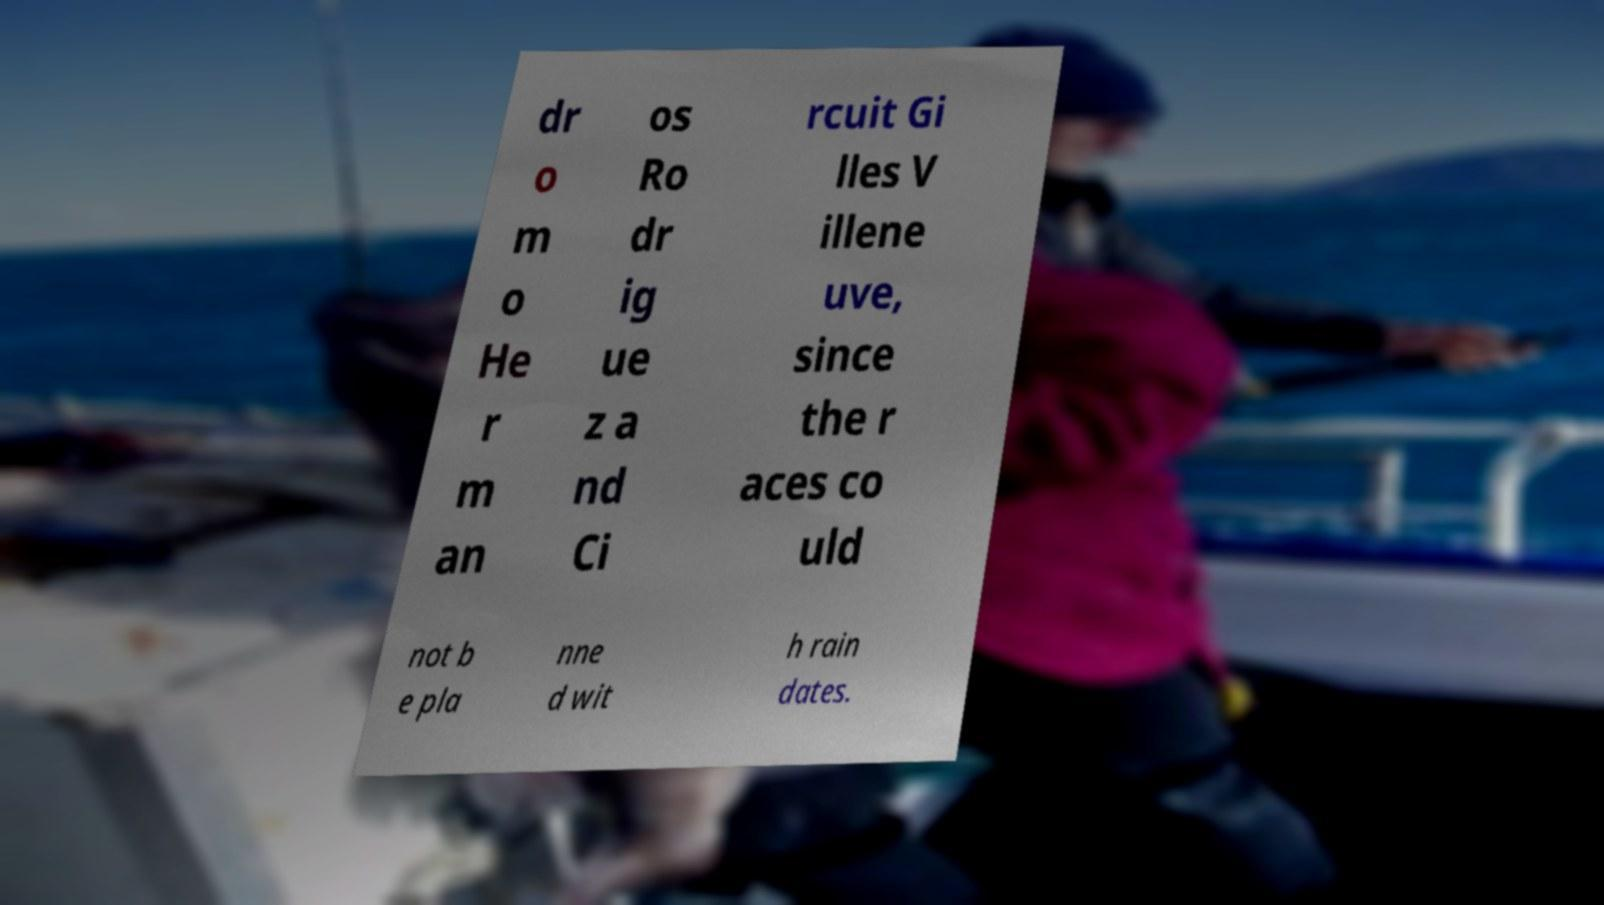Please read and relay the text visible in this image. What does it say? dr o m o He r m an os Ro dr ig ue z a nd Ci rcuit Gi lles V illene uve, since the r aces co uld not b e pla nne d wit h rain dates. 